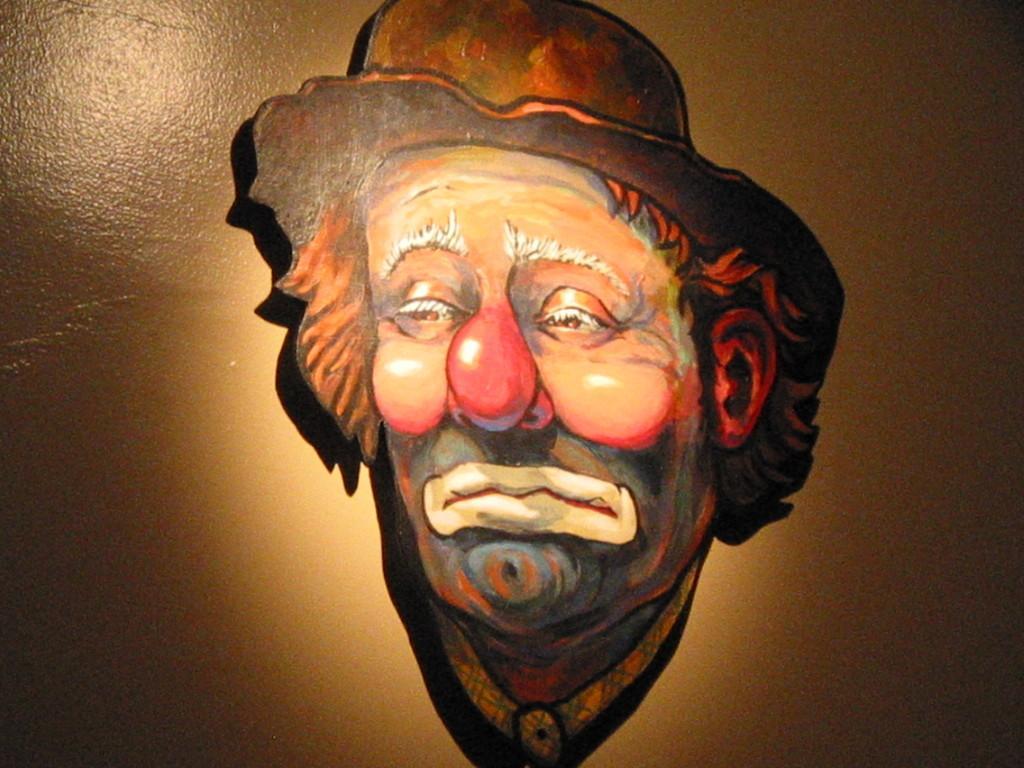Please provide a concise description of this image. In this picture we can see mask attached to the wall. 